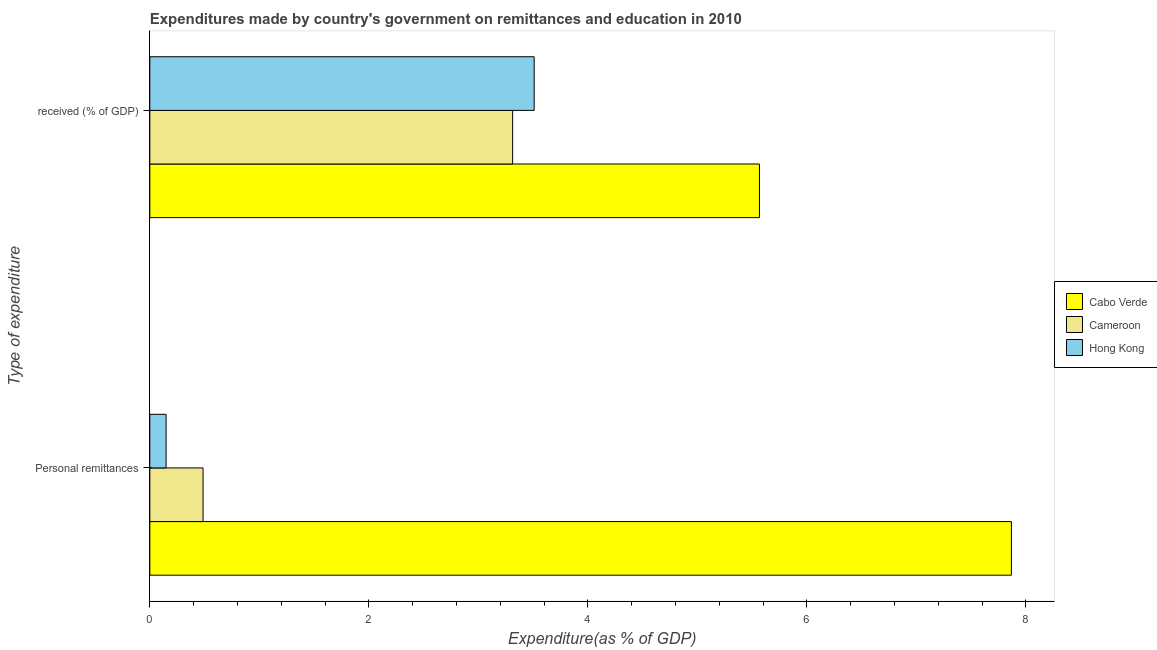How many groups of bars are there?
Ensure brevity in your answer.  2. How many bars are there on the 2nd tick from the top?
Offer a terse response. 3. How many bars are there on the 2nd tick from the bottom?
Provide a succinct answer. 3. What is the label of the 1st group of bars from the top?
Provide a short and direct response.  received (% of GDP). What is the expenditure in education in Cameroon?
Provide a succinct answer. 3.31. Across all countries, what is the maximum expenditure in education?
Your response must be concise. 5.57. Across all countries, what is the minimum expenditure in education?
Your answer should be compact. 3.31. In which country was the expenditure in education maximum?
Provide a succinct answer. Cabo Verde. In which country was the expenditure in personal remittances minimum?
Your response must be concise. Hong Kong. What is the total expenditure in personal remittances in the graph?
Your answer should be very brief. 8.5. What is the difference between the expenditure in education in Cabo Verde and that in Hong Kong?
Provide a succinct answer. 2.06. What is the difference between the expenditure in education in Cabo Verde and the expenditure in personal remittances in Hong Kong?
Your answer should be very brief. 5.42. What is the average expenditure in personal remittances per country?
Offer a very short reply. 2.83. What is the difference between the expenditure in education and expenditure in personal remittances in Cameroon?
Keep it short and to the point. 2.83. In how many countries, is the expenditure in personal remittances greater than 0.8 %?
Your answer should be very brief. 1. What is the ratio of the expenditure in personal remittances in Cabo Verde to that in Cameroon?
Give a very brief answer. 16.18. What does the 3rd bar from the top in Personal remittances represents?
Ensure brevity in your answer.  Cabo Verde. What does the 3rd bar from the bottom in Personal remittances represents?
Keep it short and to the point. Hong Kong. Are all the bars in the graph horizontal?
Offer a terse response. Yes. How many countries are there in the graph?
Provide a short and direct response. 3. What is the difference between two consecutive major ticks on the X-axis?
Your answer should be very brief. 2. Does the graph contain any zero values?
Provide a short and direct response. No. Does the graph contain grids?
Your answer should be very brief. No. How are the legend labels stacked?
Make the answer very short. Vertical. What is the title of the graph?
Keep it short and to the point. Expenditures made by country's government on remittances and education in 2010. Does "Liechtenstein" appear as one of the legend labels in the graph?
Your answer should be very brief. No. What is the label or title of the X-axis?
Provide a short and direct response. Expenditure(as % of GDP). What is the label or title of the Y-axis?
Offer a very short reply. Type of expenditure. What is the Expenditure(as % of GDP) of Cabo Verde in Personal remittances?
Your answer should be very brief. 7.87. What is the Expenditure(as % of GDP) in Cameroon in Personal remittances?
Provide a short and direct response. 0.49. What is the Expenditure(as % of GDP) in Hong Kong in Personal remittances?
Offer a terse response. 0.15. What is the Expenditure(as % of GDP) in Cabo Verde in  received (% of GDP)?
Offer a very short reply. 5.57. What is the Expenditure(as % of GDP) in Cameroon in  received (% of GDP)?
Your answer should be compact. 3.31. What is the Expenditure(as % of GDP) in Hong Kong in  received (% of GDP)?
Your answer should be very brief. 3.51. Across all Type of expenditure, what is the maximum Expenditure(as % of GDP) in Cabo Verde?
Your response must be concise. 7.87. Across all Type of expenditure, what is the maximum Expenditure(as % of GDP) of Cameroon?
Offer a terse response. 3.31. Across all Type of expenditure, what is the maximum Expenditure(as % of GDP) in Hong Kong?
Your answer should be compact. 3.51. Across all Type of expenditure, what is the minimum Expenditure(as % of GDP) of Cabo Verde?
Ensure brevity in your answer.  5.57. Across all Type of expenditure, what is the minimum Expenditure(as % of GDP) in Cameroon?
Make the answer very short. 0.49. Across all Type of expenditure, what is the minimum Expenditure(as % of GDP) of Hong Kong?
Your answer should be compact. 0.15. What is the total Expenditure(as % of GDP) in Cabo Verde in the graph?
Keep it short and to the point. 13.44. What is the total Expenditure(as % of GDP) in Cameroon in the graph?
Ensure brevity in your answer.  3.8. What is the total Expenditure(as % of GDP) in Hong Kong in the graph?
Provide a succinct answer. 3.66. What is the difference between the Expenditure(as % of GDP) in Cabo Verde in Personal remittances and that in  received (% of GDP)?
Keep it short and to the point. 2.3. What is the difference between the Expenditure(as % of GDP) of Cameroon in Personal remittances and that in  received (% of GDP)?
Provide a short and direct response. -2.83. What is the difference between the Expenditure(as % of GDP) of Hong Kong in Personal remittances and that in  received (% of GDP)?
Your answer should be very brief. -3.36. What is the difference between the Expenditure(as % of GDP) of Cabo Verde in Personal remittances and the Expenditure(as % of GDP) of Cameroon in  received (% of GDP)?
Your answer should be compact. 4.56. What is the difference between the Expenditure(as % of GDP) in Cabo Verde in Personal remittances and the Expenditure(as % of GDP) in Hong Kong in  received (% of GDP)?
Provide a short and direct response. 4.36. What is the difference between the Expenditure(as % of GDP) in Cameroon in Personal remittances and the Expenditure(as % of GDP) in Hong Kong in  received (% of GDP)?
Provide a short and direct response. -3.02. What is the average Expenditure(as % of GDP) of Cabo Verde per Type of expenditure?
Offer a terse response. 6.72. What is the average Expenditure(as % of GDP) of Cameroon per Type of expenditure?
Offer a terse response. 1.9. What is the average Expenditure(as % of GDP) in Hong Kong per Type of expenditure?
Give a very brief answer. 1.83. What is the difference between the Expenditure(as % of GDP) of Cabo Verde and Expenditure(as % of GDP) of Cameroon in Personal remittances?
Keep it short and to the point. 7.38. What is the difference between the Expenditure(as % of GDP) of Cabo Verde and Expenditure(as % of GDP) of Hong Kong in Personal remittances?
Your response must be concise. 7.72. What is the difference between the Expenditure(as % of GDP) of Cameroon and Expenditure(as % of GDP) of Hong Kong in Personal remittances?
Offer a terse response. 0.34. What is the difference between the Expenditure(as % of GDP) in Cabo Verde and Expenditure(as % of GDP) in Cameroon in  received (% of GDP)?
Your response must be concise. 2.25. What is the difference between the Expenditure(as % of GDP) of Cabo Verde and Expenditure(as % of GDP) of Hong Kong in  received (% of GDP)?
Give a very brief answer. 2.06. What is the difference between the Expenditure(as % of GDP) in Cameroon and Expenditure(as % of GDP) in Hong Kong in  received (% of GDP)?
Provide a succinct answer. -0.2. What is the ratio of the Expenditure(as % of GDP) in Cabo Verde in Personal remittances to that in  received (% of GDP)?
Ensure brevity in your answer.  1.41. What is the ratio of the Expenditure(as % of GDP) of Cameroon in Personal remittances to that in  received (% of GDP)?
Offer a very short reply. 0.15. What is the ratio of the Expenditure(as % of GDP) in Hong Kong in Personal remittances to that in  received (% of GDP)?
Ensure brevity in your answer.  0.04. What is the difference between the highest and the second highest Expenditure(as % of GDP) of Cabo Verde?
Your answer should be very brief. 2.3. What is the difference between the highest and the second highest Expenditure(as % of GDP) in Cameroon?
Make the answer very short. 2.83. What is the difference between the highest and the second highest Expenditure(as % of GDP) in Hong Kong?
Offer a very short reply. 3.36. What is the difference between the highest and the lowest Expenditure(as % of GDP) in Cabo Verde?
Ensure brevity in your answer.  2.3. What is the difference between the highest and the lowest Expenditure(as % of GDP) of Cameroon?
Your response must be concise. 2.83. What is the difference between the highest and the lowest Expenditure(as % of GDP) of Hong Kong?
Offer a terse response. 3.36. 